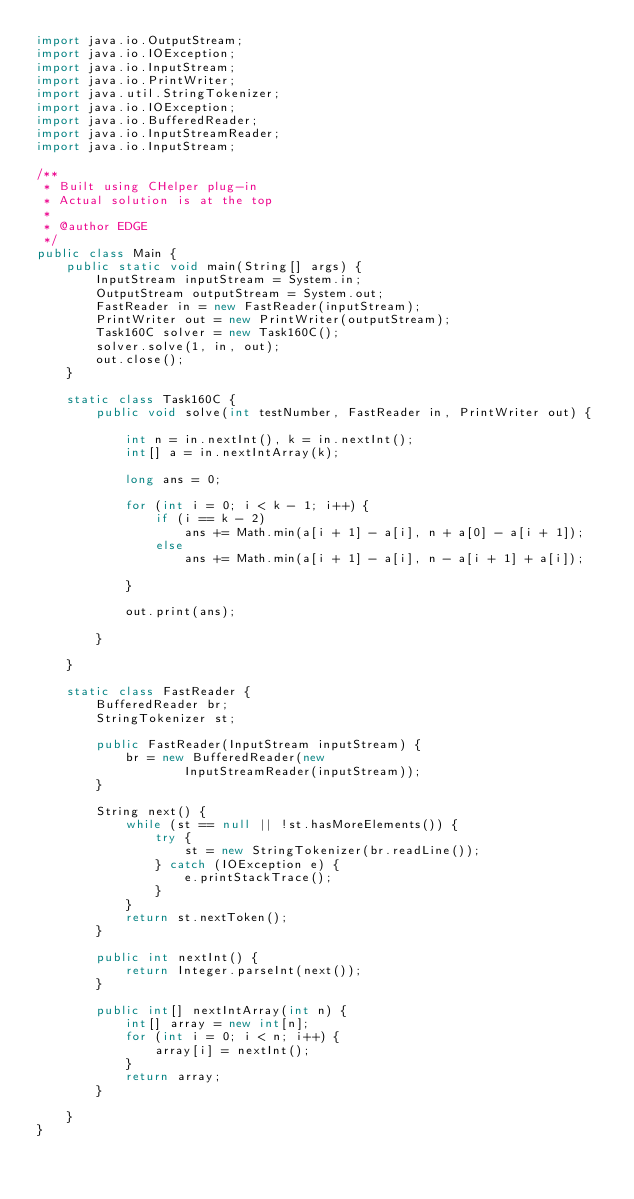Convert code to text. <code><loc_0><loc_0><loc_500><loc_500><_Java_>import java.io.OutputStream;
import java.io.IOException;
import java.io.InputStream;
import java.io.PrintWriter;
import java.util.StringTokenizer;
import java.io.IOException;
import java.io.BufferedReader;
import java.io.InputStreamReader;
import java.io.InputStream;

/**
 * Built using CHelper plug-in
 * Actual solution is at the top
 *
 * @author EDGE
 */
public class Main {
    public static void main(String[] args) {
        InputStream inputStream = System.in;
        OutputStream outputStream = System.out;
        FastReader in = new FastReader(inputStream);
        PrintWriter out = new PrintWriter(outputStream);
        Task160C solver = new Task160C();
        solver.solve(1, in, out);
        out.close();
    }

    static class Task160C {
        public void solve(int testNumber, FastReader in, PrintWriter out) {

            int n = in.nextInt(), k = in.nextInt();
            int[] a = in.nextIntArray(k);

            long ans = 0;

            for (int i = 0; i < k - 1; i++) {
                if (i == k - 2)
                    ans += Math.min(a[i + 1] - a[i], n + a[0] - a[i + 1]);
                else
                    ans += Math.min(a[i + 1] - a[i], n - a[i + 1] + a[i]);

            }

            out.print(ans);

        }

    }

    static class FastReader {
        BufferedReader br;
        StringTokenizer st;

        public FastReader(InputStream inputStream) {
            br = new BufferedReader(new
                    InputStreamReader(inputStream));
        }

        String next() {
            while (st == null || !st.hasMoreElements()) {
                try {
                    st = new StringTokenizer(br.readLine());
                } catch (IOException e) {
                    e.printStackTrace();
                }
            }
            return st.nextToken();
        }

        public int nextInt() {
            return Integer.parseInt(next());
        }

        public int[] nextIntArray(int n) {
            int[] array = new int[n];
            for (int i = 0; i < n; i++) {
                array[i] = nextInt();
            }
            return array;
        }

    }
}

</code> 